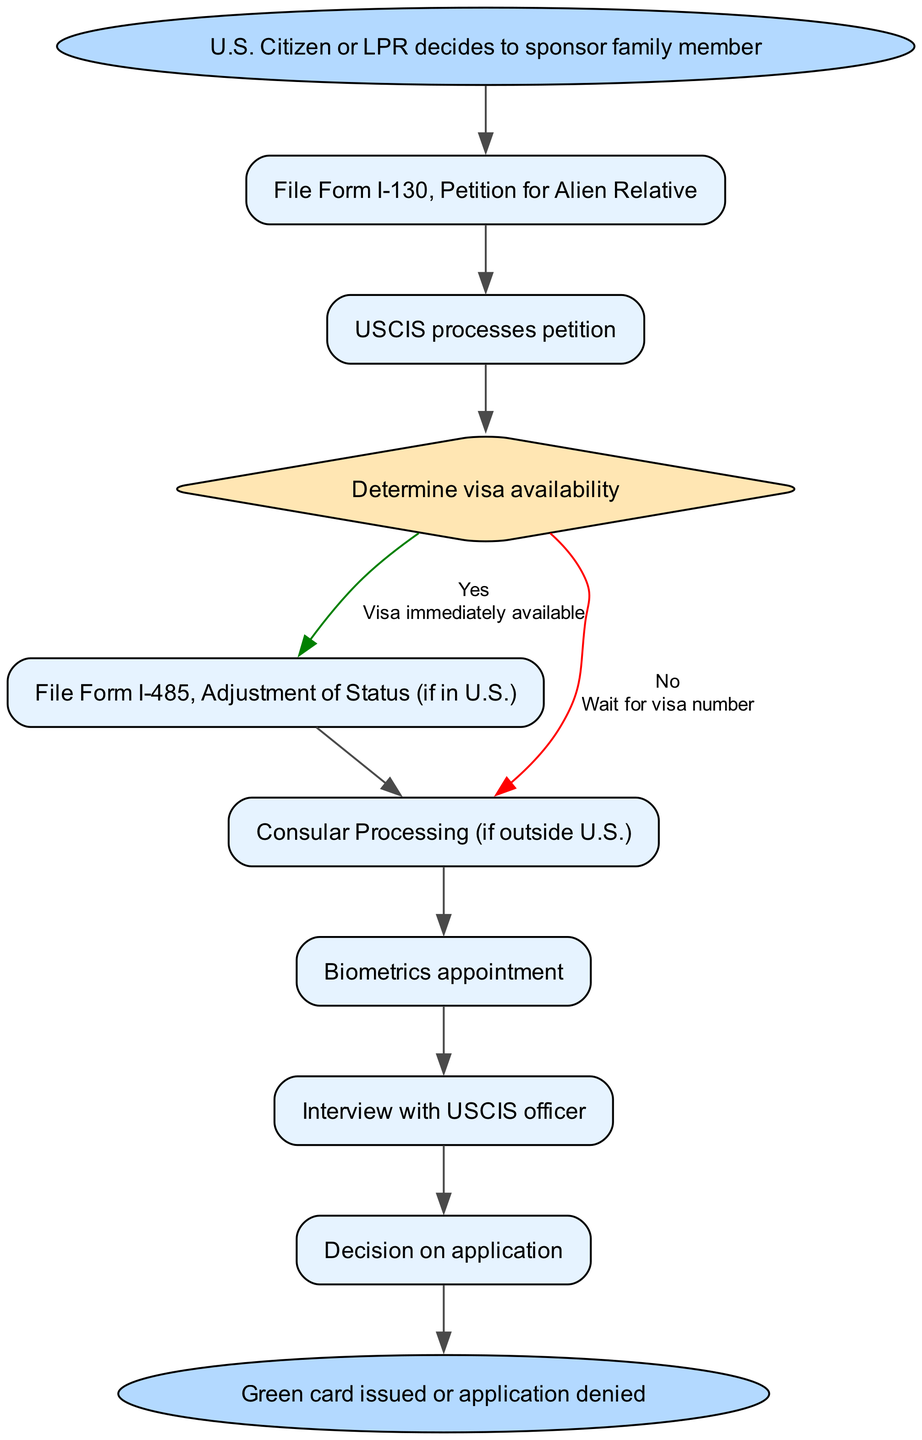What is the first step in the workflow? The first step, as indicated in the diagram, is initiated by the U.S. Citizen or Lawful Permanent Resident deciding to sponsor a family member. This is represented at the start of the flowchart.
Answer: U.S. Citizen or LPR decides to sponsor family member How many steps are there in total? The diagram includes eight distinct steps listed from Step 1 to Step 8, representing different actions and decisions in the family-based immigration sponsorship workflow.
Answer: Eight What form is filed in the first step? The first step in the diagram indicates that the Form I-130, Petition for Alien Relative, is filed. This is specifically mentioned as part of the workflow steps.
Answer: Form I-130, Petition for Alien Relative What happens if the visa is available? The diagram specifies that if the visa is immediately available, the next step involves filing Form I-485, Adjustment of Status. This is highlighted for the "Yes" branch of the decision node regarding visa availability.
Answer: File Form I-485, Adjustment of Status (if in U.S.) What is the end result of the workflow? The end of the workflow indicates two possible outcomes: either a green card is issued or the application is denied. This is shown clearly as the final node leading from the last step.
Answer: Green card issued or application denied What is the last action taken in the process? The final action taken in the process, as shown in the diagram, is the decision on the application, which leads to the end result. This occurs immediately before reaching the end node.
Answer: Decision on application What step involves interaction with USCIS? Two steps require direct interaction with USCIS: the biometrics appointment and the interview with a USCIS officer, which are highlighted as part of the application process.
Answer: Interview with USCIS officer What is required for Consular Processing? The diagram indicates that if the applicant is outside the U.S., the action taken is Consular Processing, which is identified as a separate step from Adjustment of Status.
Answer: Consular Processing (if outside U.S.) 